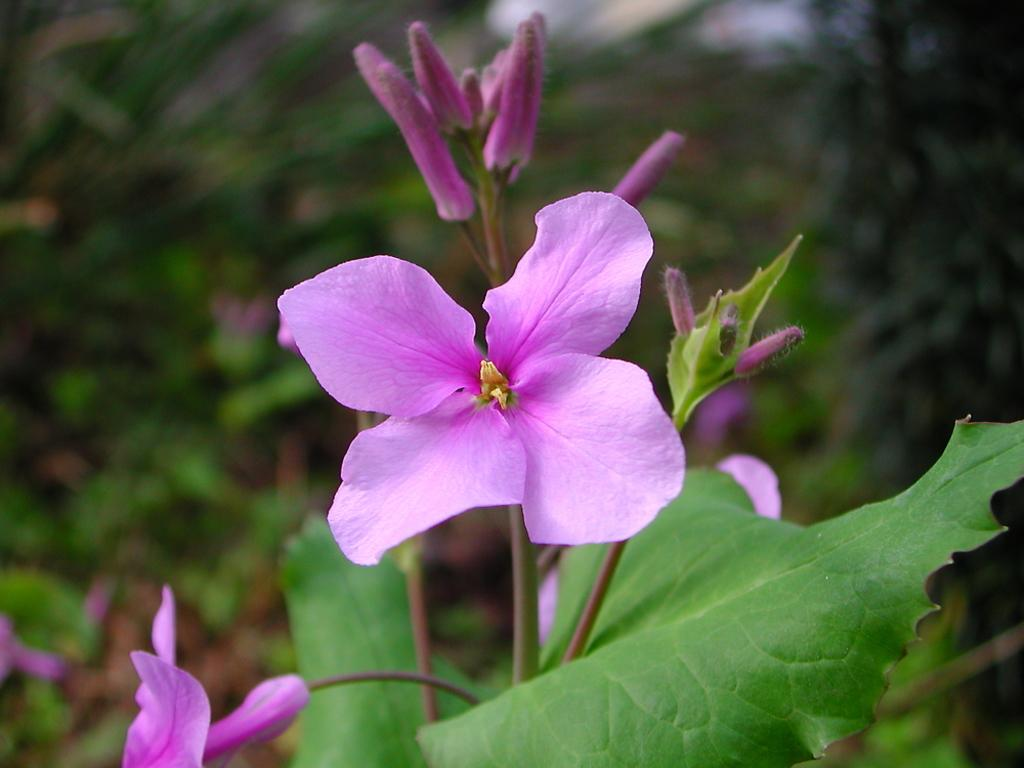What type of living organism can be seen in the image? There is a plant in the image. What specific part of the plant is visible? There is a flower in the image. Can you describe the background of the image? The background of the image is blurred. What type of cap is the plant wearing in the image? There is no cap present on the plant in the image. 